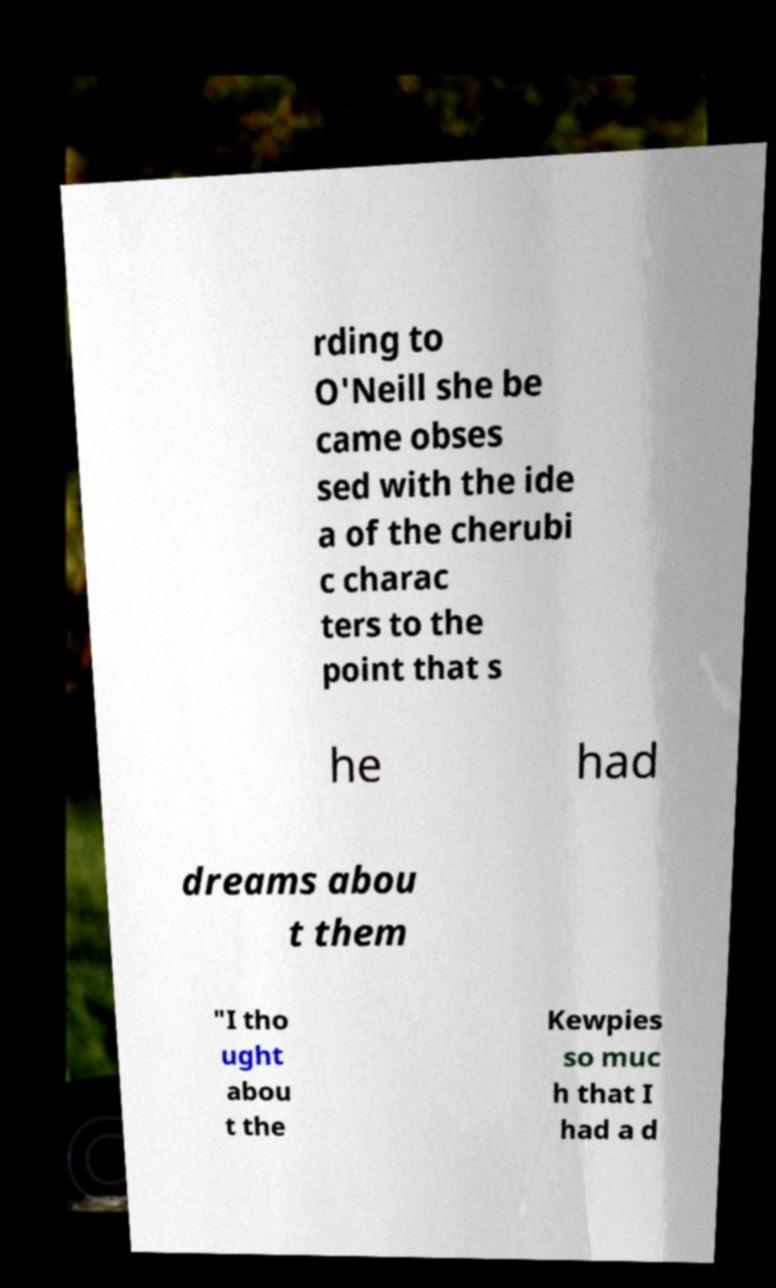Could you extract and type out the text from this image? rding to O'Neill she be came obses sed with the ide a of the cherubi c charac ters to the point that s he had dreams abou t them "I tho ught abou t the Kewpies so muc h that I had a d 